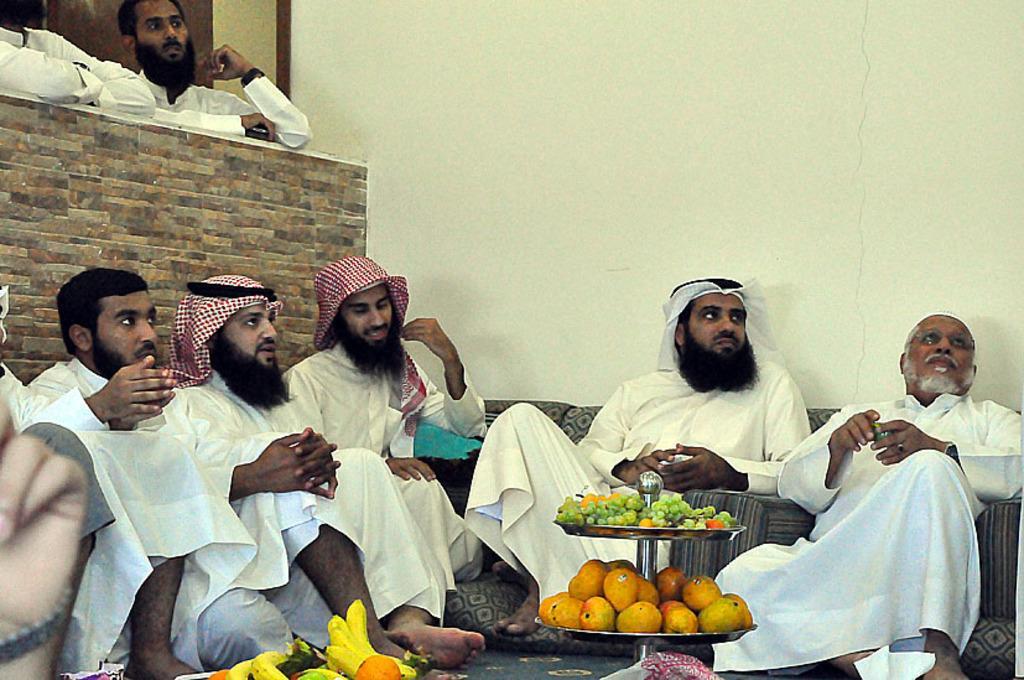How would you summarize this image in a sentence or two? In this image I can see there are few persons sitting on the floor, in front of them I can see plates, on the plates I can see fruits and some fruits kept on the floor. In the background I can see the wall, on the left side I can see wall, in front of the wall I can see two persons standing back side of the wall. 